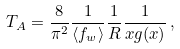Convert formula to latex. <formula><loc_0><loc_0><loc_500><loc_500>T _ { A } = \frac { 8 } { \pi ^ { 2 } } \frac { 1 } { \langle f _ { w } \rangle } \frac { 1 } { R } \frac { 1 } { x g ( x ) } \, ,</formula> 